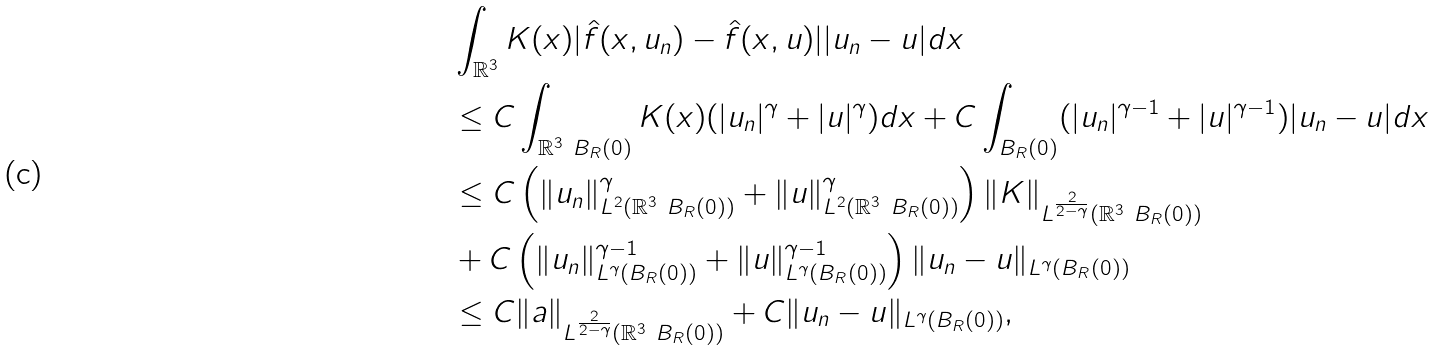<formula> <loc_0><loc_0><loc_500><loc_500>& \int _ { \mathbb { R } ^ { 3 } } K ( x ) | \hat { f } ( x , u _ { n } ) - \hat { f } ( x , u ) | | u _ { n } - u | d x \\ & \leq C \int _ { \mathbb { R } ^ { 3 } \ B _ { R } ( 0 ) } K ( x ) ( | u _ { n } | ^ { \gamma } + | u | ^ { \gamma } ) d x + C \int _ { B _ { R } ( 0 ) } ( | u _ { n } | ^ { \gamma - 1 } + | u | ^ { \gamma - 1 } ) | u _ { n } - u | d x \\ & \leq C \left ( \| u _ { n } \| ^ { \gamma } _ { L ^ { 2 } ( \mathbb { R } ^ { 3 } \ B _ { R } ( 0 ) ) } + \| u \| ^ { \gamma } _ { L ^ { 2 } ( \mathbb { R } ^ { 3 } \ B _ { R } ( 0 ) ) } \right ) \| K \| _ { L ^ { \frac { 2 } { 2 - \gamma } } ( \mathbb { R } ^ { 3 } \ B _ { R } ( 0 ) ) } \\ & + C \left ( \| u _ { n } \| ^ { \gamma - 1 } _ { L ^ { \gamma } ( B _ { R } ( 0 ) ) } + \| u \| ^ { \gamma - 1 } _ { L ^ { \gamma } ( B _ { R } ( 0 ) ) } \right ) \| u _ { n } - u \| _ { L ^ { \gamma } ( B _ { R } ( 0 ) ) } \\ & \leq C \| a \| _ { L ^ { \frac { 2 } { 2 - \gamma } } ( \mathbb { R } ^ { 3 } \ B _ { R } ( 0 ) ) } + C \| u _ { n } - u \| _ { L ^ { \gamma } ( B _ { R } ( 0 ) ) } ,</formula> 